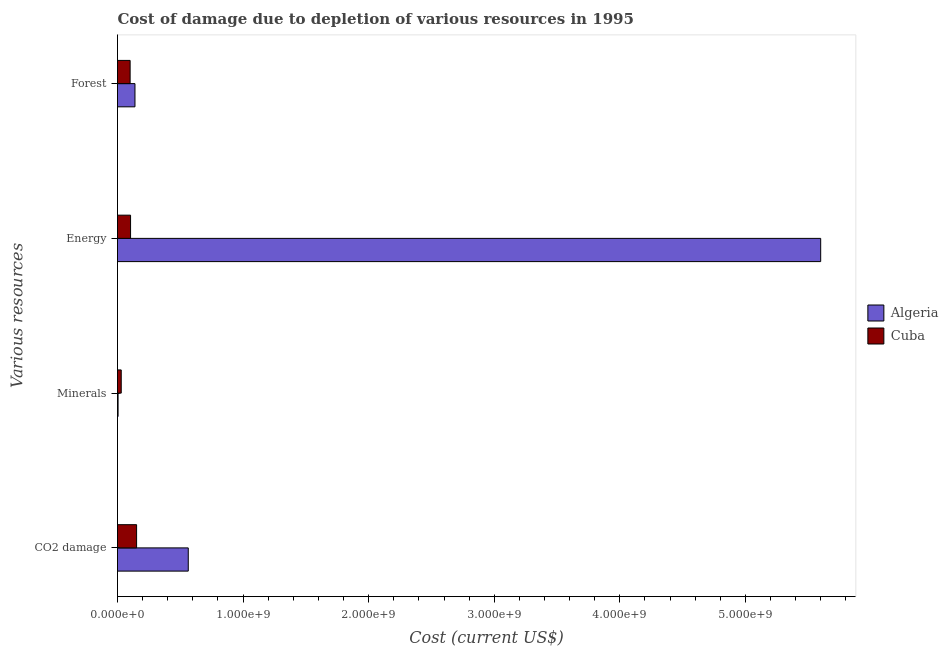How many groups of bars are there?
Make the answer very short. 4. How many bars are there on the 1st tick from the top?
Keep it short and to the point. 2. How many bars are there on the 3rd tick from the bottom?
Provide a succinct answer. 2. What is the label of the 2nd group of bars from the top?
Provide a short and direct response. Energy. What is the cost of damage due to depletion of coal in Cuba?
Your answer should be compact. 1.52e+08. Across all countries, what is the maximum cost of damage due to depletion of minerals?
Your answer should be very brief. 2.97e+07. Across all countries, what is the minimum cost of damage due to depletion of forests?
Offer a very short reply. 1.00e+08. In which country was the cost of damage due to depletion of coal maximum?
Your answer should be compact. Algeria. In which country was the cost of damage due to depletion of forests minimum?
Provide a succinct answer. Cuba. What is the total cost of damage due to depletion of energy in the graph?
Your answer should be compact. 5.70e+09. What is the difference between the cost of damage due to depletion of minerals in Algeria and that in Cuba?
Your answer should be very brief. -2.51e+07. What is the difference between the cost of damage due to depletion of coal in Cuba and the cost of damage due to depletion of forests in Algeria?
Keep it short and to the point. 1.29e+07. What is the average cost of damage due to depletion of forests per country?
Ensure brevity in your answer.  1.20e+08. What is the difference between the cost of damage due to depletion of energy and cost of damage due to depletion of coal in Algeria?
Offer a very short reply. 5.04e+09. What is the ratio of the cost of damage due to depletion of forests in Algeria to that in Cuba?
Your response must be concise. 1.38. Is the cost of damage due to depletion of energy in Algeria less than that in Cuba?
Give a very brief answer. No. What is the difference between the highest and the second highest cost of damage due to depletion of coal?
Your answer should be compact. 4.12e+08. What is the difference between the highest and the lowest cost of damage due to depletion of energy?
Provide a short and direct response. 5.50e+09. In how many countries, is the cost of damage due to depletion of energy greater than the average cost of damage due to depletion of energy taken over all countries?
Provide a succinct answer. 1. Is the sum of the cost of damage due to depletion of coal in Cuba and Algeria greater than the maximum cost of damage due to depletion of minerals across all countries?
Offer a terse response. Yes. Is it the case that in every country, the sum of the cost of damage due to depletion of minerals and cost of damage due to depletion of energy is greater than the sum of cost of damage due to depletion of forests and cost of damage due to depletion of coal?
Your answer should be very brief. No. What does the 1st bar from the top in Forest represents?
Your answer should be compact. Cuba. What does the 2nd bar from the bottom in Forest represents?
Offer a terse response. Cuba. Is it the case that in every country, the sum of the cost of damage due to depletion of coal and cost of damage due to depletion of minerals is greater than the cost of damage due to depletion of energy?
Offer a very short reply. No. How many countries are there in the graph?
Provide a short and direct response. 2. What is the difference between two consecutive major ticks on the X-axis?
Your response must be concise. 1.00e+09. Are the values on the major ticks of X-axis written in scientific E-notation?
Your answer should be compact. Yes. Where does the legend appear in the graph?
Ensure brevity in your answer.  Center right. How many legend labels are there?
Make the answer very short. 2. How are the legend labels stacked?
Offer a terse response. Vertical. What is the title of the graph?
Ensure brevity in your answer.  Cost of damage due to depletion of various resources in 1995 . Does "Hungary" appear as one of the legend labels in the graph?
Offer a very short reply. No. What is the label or title of the X-axis?
Offer a very short reply. Cost (current US$). What is the label or title of the Y-axis?
Offer a very short reply. Various resources. What is the Cost (current US$) of Algeria in CO2 damage?
Your response must be concise. 5.63e+08. What is the Cost (current US$) in Cuba in CO2 damage?
Your answer should be very brief. 1.52e+08. What is the Cost (current US$) of Algeria in Minerals?
Provide a short and direct response. 4.58e+06. What is the Cost (current US$) of Cuba in Minerals?
Give a very brief answer. 2.97e+07. What is the Cost (current US$) of Algeria in Energy?
Offer a terse response. 5.60e+09. What is the Cost (current US$) of Cuba in Energy?
Offer a very short reply. 1.04e+08. What is the Cost (current US$) of Algeria in Forest?
Give a very brief answer. 1.39e+08. What is the Cost (current US$) in Cuba in Forest?
Your response must be concise. 1.00e+08. Across all Various resources, what is the maximum Cost (current US$) in Algeria?
Your response must be concise. 5.60e+09. Across all Various resources, what is the maximum Cost (current US$) of Cuba?
Keep it short and to the point. 1.52e+08. Across all Various resources, what is the minimum Cost (current US$) of Algeria?
Offer a terse response. 4.58e+06. Across all Various resources, what is the minimum Cost (current US$) of Cuba?
Provide a short and direct response. 2.97e+07. What is the total Cost (current US$) of Algeria in the graph?
Offer a very short reply. 6.31e+09. What is the total Cost (current US$) of Cuba in the graph?
Give a very brief answer. 3.86e+08. What is the difference between the Cost (current US$) in Algeria in CO2 damage and that in Minerals?
Offer a terse response. 5.59e+08. What is the difference between the Cost (current US$) in Cuba in CO2 damage and that in Minerals?
Provide a succinct answer. 1.22e+08. What is the difference between the Cost (current US$) of Algeria in CO2 damage and that in Energy?
Keep it short and to the point. -5.04e+09. What is the difference between the Cost (current US$) of Cuba in CO2 damage and that in Energy?
Offer a very short reply. 4.80e+07. What is the difference between the Cost (current US$) in Algeria in CO2 damage and that in Forest?
Your answer should be compact. 4.24e+08. What is the difference between the Cost (current US$) of Cuba in CO2 damage and that in Forest?
Offer a terse response. 5.15e+07. What is the difference between the Cost (current US$) of Algeria in Minerals and that in Energy?
Your answer should be compact. -5.59e+09. What is the difference between the Cost (current US$) of Cuba in Minerals and that in Energy?
Make the answer very short. -7.42e+07. What is the difference between the Cost (current US$) of Algeria in Minerals and that in Forest?
Ensure brevity in your answer.  -1.34e+08. What is the difference between the Cost (current US$) in Cuba in Minerals and that in Forest?
Your answer should be very brief. -7.07e+07. What is the difference between the Cost (current US$) of Algeria in Energy and that in Forest?
Provide a succinct answer. 5.46e+09. What is the difference between the Cost (current US$) in Cuba in Energy and that in Forest?
Give a very brief answer. 3.47e+06. What is the difference between the Cost (current US$) in Algeria in CO2 damage and the Cost (current US$) in Cuba in Minerals?
Your answer should be compact. 5.34e+08. What is the difference between the Cost (current US$) in Algeria in CO2 damage and the Cost (current US$) in Cuba in Energy?
Offer a very short reply. 4.60e+08. What is the difference between the Cost (current US$) in Algeria in CO2 damage and the Cost (current US$) in Cuba in Forest?
Ensure brevity in your answer.  4.63e+08. What is the difference between the Cost (current US$) in Algeria in Minerals and the Cost (current US$) in Cuba in Energy?
Provide a short and direct response. -9.93e+07. What is the difference between the Cost (current US$) in Algeria in Minerals and the Cost (current US$) in Cuba in Forest?
Your answer should be very brief. -9.59e+07. What is the difference between the Cost (current US$) in Algeria in Energy and the Cost (current US$) in Cuba in Forest?
Your response must be concise. 5.50e+09. What is the average Cost (current US$) of Algeria per Various resources?
Give a very brief answer. 1.58e+09. What is the average Cost (current US$) in Cuba per Various resources?
Your answer should be very brief. 9.65e+07. What is the difference between the Cost (current US$) in Algeria and Cost (current US$) in Cuba in CO2 damage?
Offer a terse response. 4.12e+08. What is the difference between the Cost (current US$) in Algeria and Cost (current US$) in Cuba in Minerals?
Offer a terse response. -2.51e+07. What is the difference between the Cost (current US$) in Algeria and Cost (current US$) in Cuba in Energy?
Ensure brevity in your answer.  5.50e+09. What is the difference between the Cost (current US$) in Algeria and Cost (current US$) in Cuba in Forest?
Ensure brevity in your answer.  3.86e+07. What is the ratio of the Cost (current US$) in Algeria in CO2 damage to that in Minerals?
Your answer should be very brief. 123.15. What is the ratio of the Cost (current US$) in Cuba in CO2 damage to that in Minerals?
Offer a terse response. 5.11. What is the ratio of the Cost (current US$) of Algeria in CO2 damage to that in Energy?
Your answer should be very brief. 0.1. What is the ratio of the Cost (current US$) in Cuba in CO2 damage to that in Energy?
Make the answer very short. 1.46. What is the ratio of the Cost (current US$) of Algeria in CO2 damage to that in Forest?
Provide a succinct answer. 4.05. What is the ratio of the Cost (current US$) of Cuba in CO2 damage to that in Forest?
Your answer should be very brief. 1.51. What is the ratio of the Cost (current US$) of Algeria in Minerals to that in Energy?
Your answer should be very brief. 0. What is the ratio of the Cost (current US$) of Cuba in Minerals to that in Energy?
Keep it short and to the point. 0.29. What is the ratio of the Cost (current US$) in Algeria in Minerals to that in Forest?
Your answer should be very brief. 0.03. What is the ratio of the Cost (current US$) of Cuba in Minerals to that in Forest?
Give a very brief answer. 0.3. What is the ratio of the Cost (current US$) in Algeria in Energy to that in Forest?
Your response must be concise. 40.28. What is the ratio of the Cost (current US$) in Cuba in Energy to that in Forest?
Your response must be concise. 1.03. What is the difference between the highest and the second highest Cost (current US$) of Algeria?
Ensure brevity in your answer.  5.04e+09. What is the difference between the highest and the second highest Cost (current US$) of Cuba?
Offer a very short reply. 4.80e+07. What is the difference between the highest and the lowest Cost (current US$) in Algeria?
Provide a short and direct response. 5.59e+09. What is the difference between the highest and the lowest Cost (current US$) in Cuba?
Your response must be concise. 1.22e+08. 